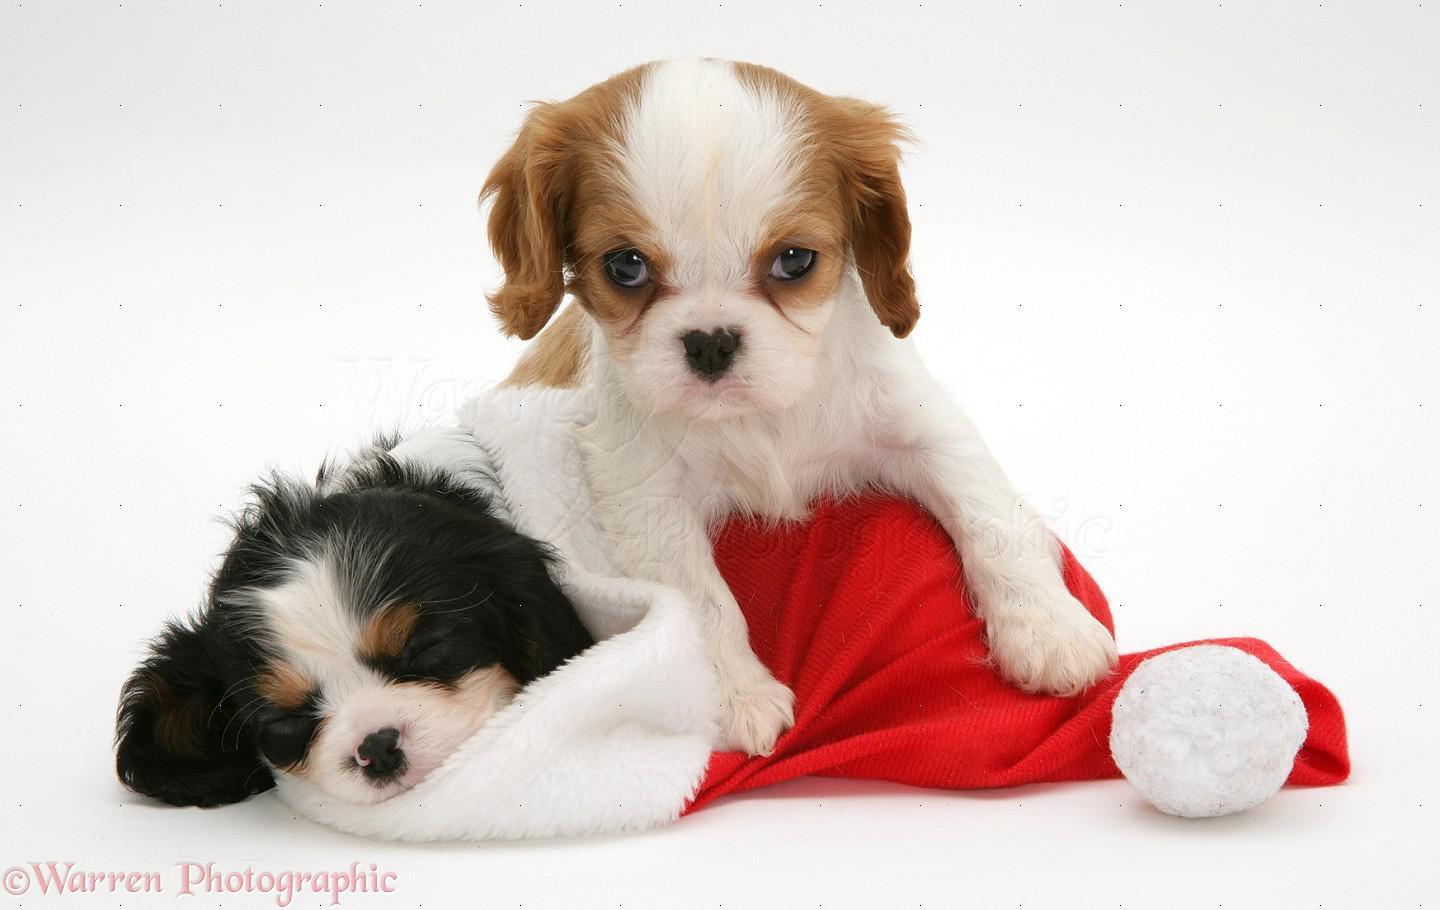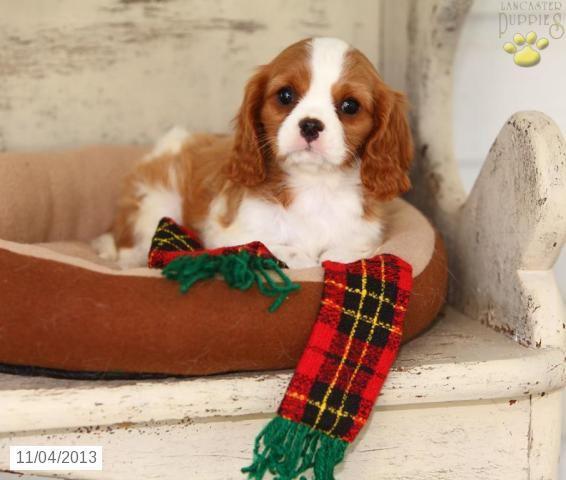The first image is the image on the left, the second image is the image on the right. Assess this claim about the two images: "The left image shows a black, white and brown dog inside a santa hat and a brown and white dog next to it". Correct or not? Answer yes or no. Yes. The first image is the image on the left, the second image is the image on the right. Evaluate the accuracy of this statement regarding the images: "An image shows one puppy in a Santa hat and another puppy behind the hat.". Is it true? Answer yes or no. Yes. 